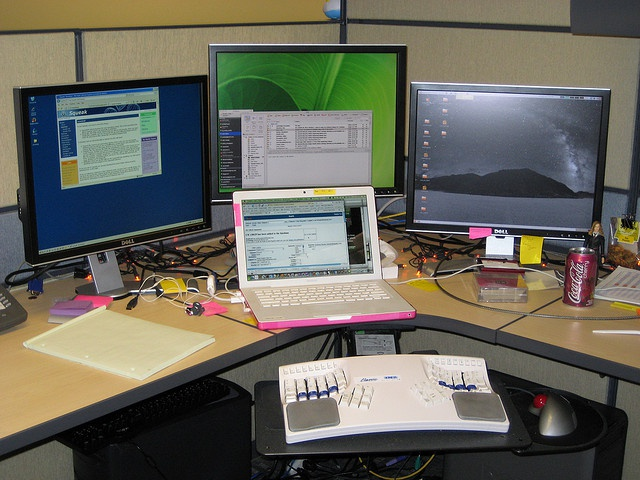Describe the objects in this image and their specific colors. I can see tv in olive, navy, black, darkgray, and gray tones, tv in olive, darkgray, darkgreen, black, and green tones, tv in olive, gray, black, and darkgray tones, laptop in olive, darkgray, lightgray, and tan tones, and keyboard in olive, lightgray, gray, and darkgray tones in this image. 